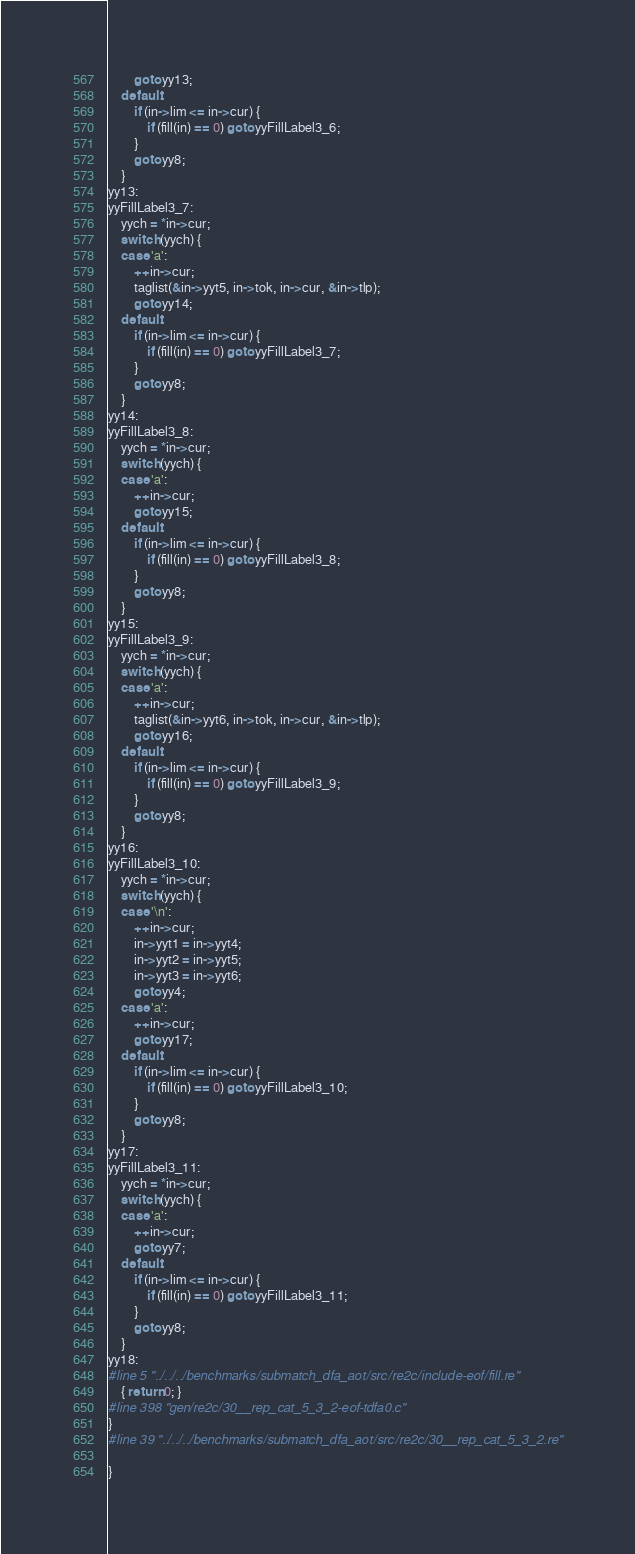<code> <loc_0><loc_0><loc_500><loc_500><_C_>		goto yy13;
	default:
		if (in->lim <= in->cur) {
			if (fill(in) == 0) goto yyFillLabel3_6;
		}
		goto yy8;
	}
yy13:
yyFillLabel3_7:
	yych = *in->cur;
	switch (yych) {
	case 'a':
		++in->cur;
		taglist(&in->yyt5, in->tok, in->cur, &in->tlp);
		goto yy14;
	default:
		if (in->lim <= in->cur) {
			if (fill(in) == 0) goto yyFillLabel3_7;
		}
		goto yy8;
	}
yy14:
yyFillLabel3_8:
	yych = *in->cur;
	switch (yych) {
	case 'a':
		++in->cur;
		goto yy15;
	default:
		if (in->lim <= in->cur) {
			if (fill(in) == 0) goto yyFillLabel3_8;
		}
		goto yy8;
	}
yy15:
yyFillLabel3_9:
	yych = *in->cur;
	switch (yych) {
	case 'a':
		++in->cur;
		taglist(&in->yyt6, in->tok, in->cur, &in->tlp);
		goto yy16;
	default:
		if (in->lim <= in->cur) {
			if (fill(in) == 0) goto yyFillLabel3_9;
		}
		goto yy8;
	}
yy16:
yyFillLabel3_10:
	yych = *in->cur;
	switch (yych) {
	case '\n':
		++in->cur;
		in->yyt1 = in->yyt4;
		in->yyt2 = in->yyt5;
		in->yyt3 = in->yyt6;
		goto yy4;
	case 'a':
		++in->cur;
		goto yy17;
	default:
		if (in->lim <= in->cur) {
			if (fill(in) == 0) goto yyFillLabel3_10;
		}
		goto yy8;
	}
yy17:
yyFillLabel3_11:
	yych = *in->cur;
	switch (yych) {
	case 'a':
		++in->cur;
		goto yy7;
	default:
		if (in->lim <= in->cur) {
			if (fill(in) == 0) goto yyFillLabel3_11;
		}
		goto yy8;
	}
yy18:
#line 5 "../../../benchmarks/submatch_dfa_aot/src/re2c/include-eof/fill.re"
	{ return 0; }
#line 398 "gen/re2c/30__rep_cat_5_3_2-eof-tdfa0.c"
}
#line 39 "../../../benchmarks/submatch_dfa_aot/src/re2c/30__rep_cat_5_3_2.re"

}
</code> 